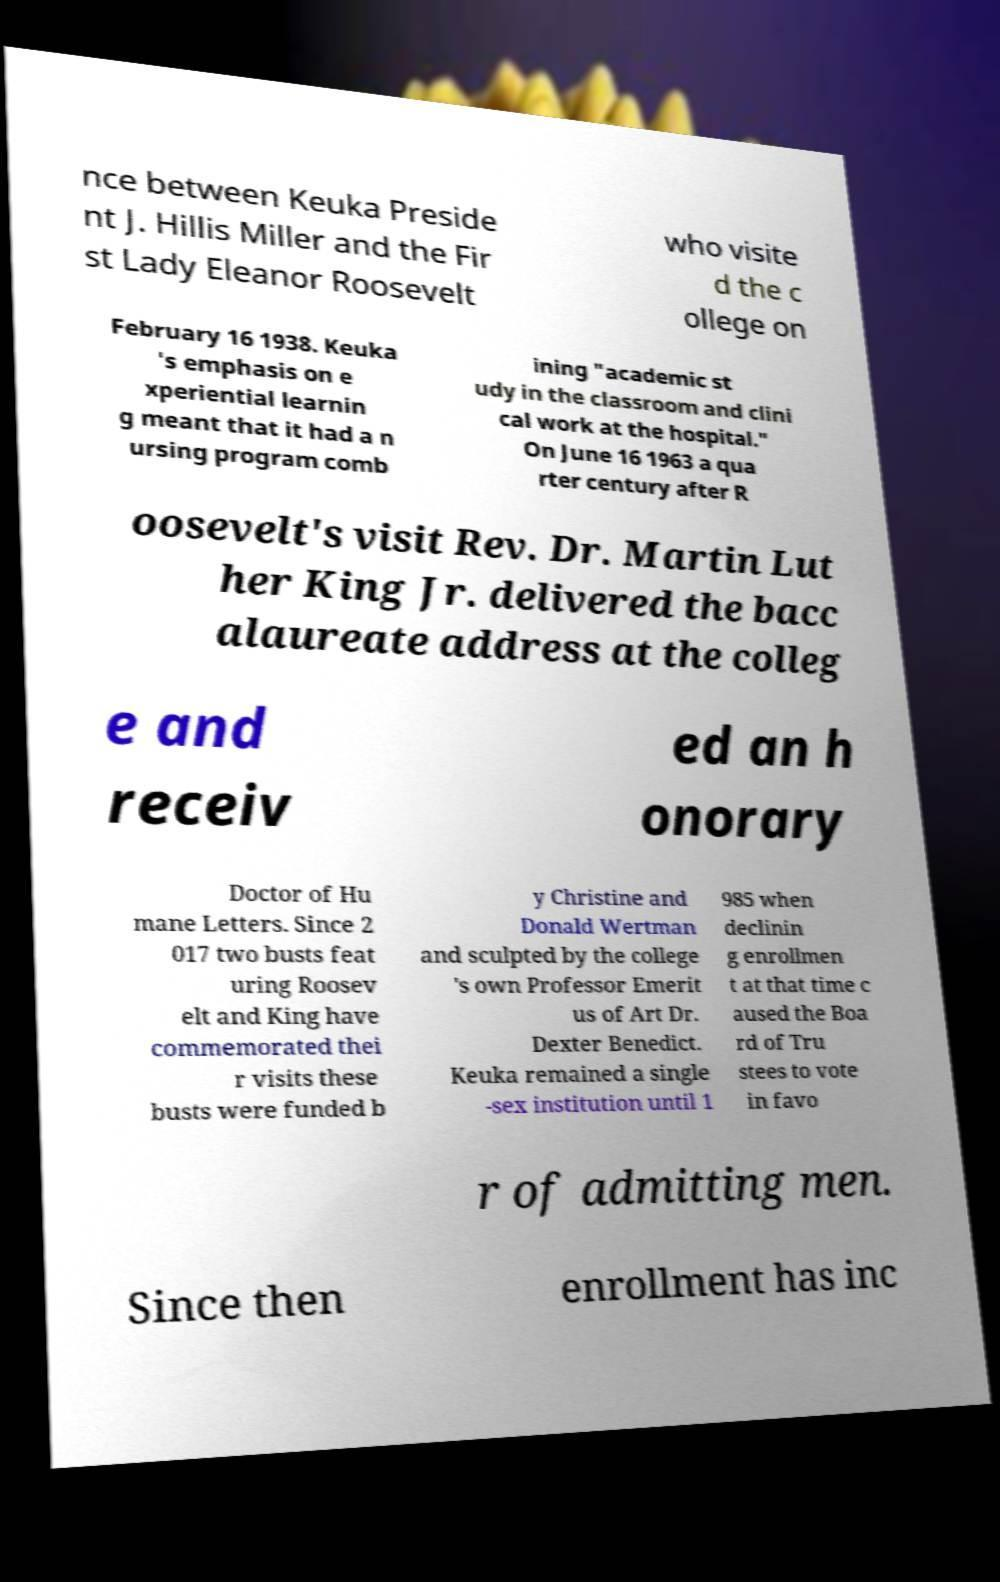I need the written content from this picture converted into text. Can you do that? nce between Keuka Preside nt J. Hillis Miller and the Fir st Lady Eleanor Roosevelt who visite d the c ollege on February 16 1938. Keuka 's emphasis on e xperiential learnin g meant that it had a n ursing program comb ining "academic st udy in the classroom and clini cal work at the hospital." On June 16 1963 a qua rter century after R oosevelt's visit Rev. Dr. Martin Lut her King Jr. delivered the bacc alaureate address at the colleg e and receiv ed an h onorary Doctor of Hu mane Letters. Since 2 017 two busts feat uring Roosev elt and King have commemorated thei r visits these busts were funded b y Christine and Donald Wertman and sculpted by the college 's own Professor Emerit us of Art Dr. Dexter Benedict. Keuka remained a single -sex institution until 1 985 when declinin g enrollmen t at that time c aused the Boa rd of Tru stees to vote in favo r of admitting men. Since then enrollment has inc 